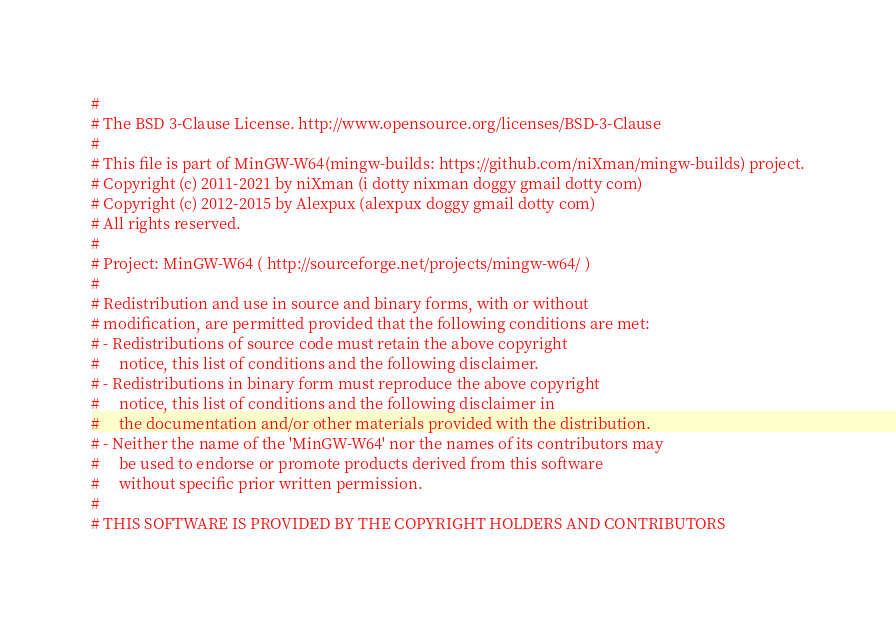<code> <loc_0><loc_0><loc_500><loc_500><_Bash_>
#
# The BSD 3-Clause License. http://www.opensource.org/licenses/BSD-3-Clause
#
# This file is part of MinGW-W64(mingw-builds: https://github.com/niXman/mingw-builds) project.
# Copyright (c) 2011-2021 by niXman (i dotty nixman doggy gmail dotty com)
# Copyright (c) 2012-2015 by Alexpux (alexpux doggy gmail dotty com)
# All rights reserved.
#
# Project: MinGW-W64 ( http://sourceforge.net/projects/mingw-w64/ )
#
# Redistribution and use in source and binary forms, with or without
# modification, are permitted provided that the following conditions are met:
# - Redistributions of source code must retain the above copyright
#     notice, this list of conditions and the following disclaimer.
# - Redistributions in binary form must reproduce the above copyright
#     notice, this list of conditions and the following disclaimer in
#     the documentation and/or other materials provided with the distribution.
# - Neither the name of the 'MinGW-W64' nor the names of its contributors may
#     be used to endorse or promote products derived from this software
#     without specific prior written permission.
#
# THIS SOFTWARE IS PROVIDED BY THE COPYRIGHT HOLDERS AND CONTRIBUTORS</code> 